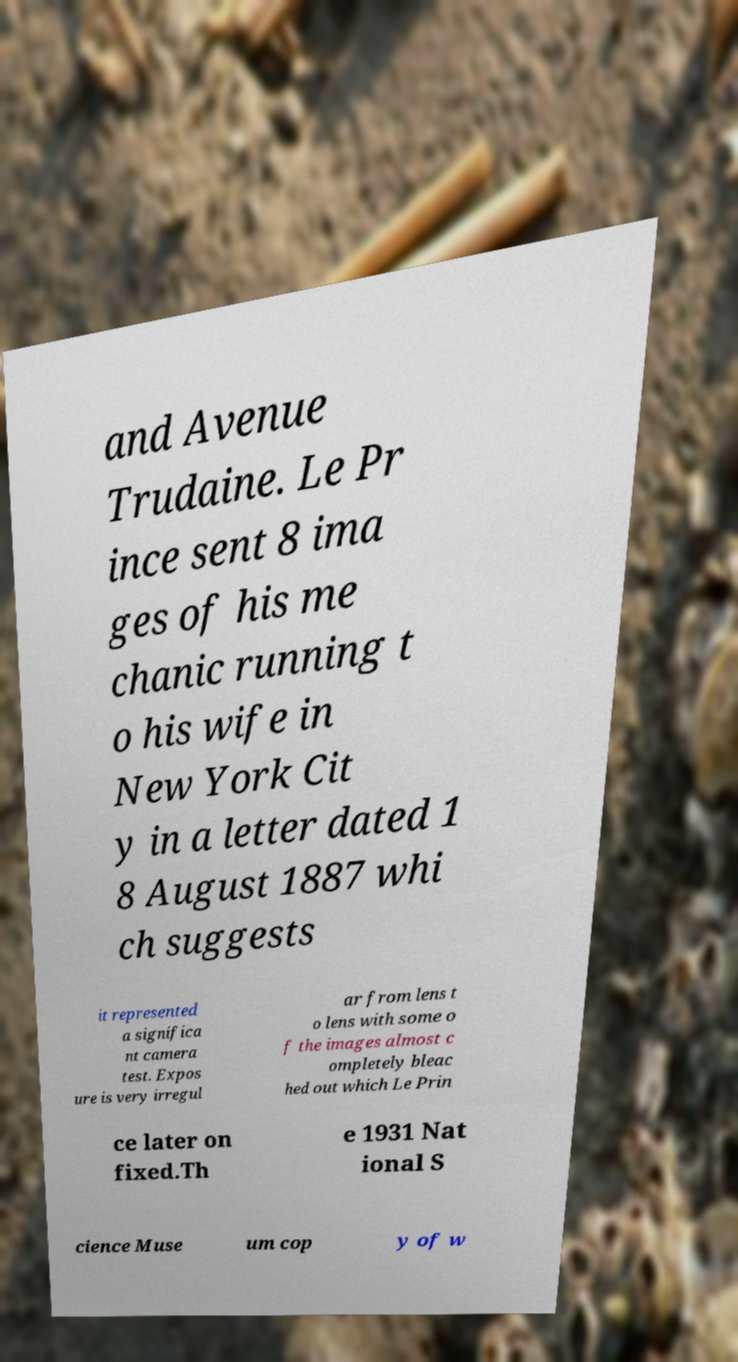Could you assist in decoding the text presented in this image and type it out clearly? and Avenue Trudaine. Le Pr ince sent 8 ima ges of his me chanic running t o his wife in New York Cit y in a letter dated 1 8 August 1887 whi ch suggests it represented a significa nt camera test. Expos ure is very irregul ar from lens t o lens with some o f the images almost c ompletely bleac hed out which Le Prin ce later on fixed.Th e 1931 Nat ional S cience Muse um cop y of w 